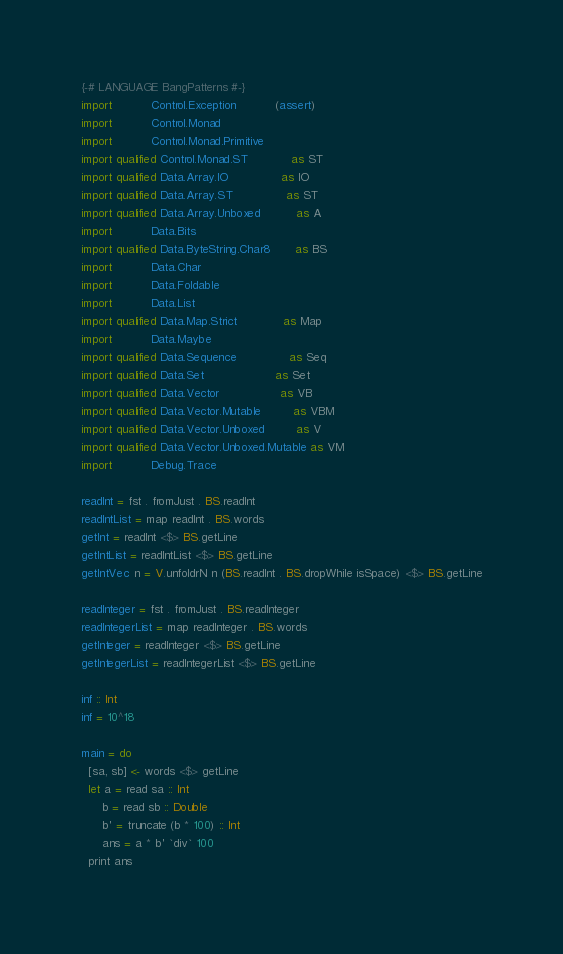<code> <loc_0><loc_0><loc_500><loc_500><_Haskell_>{-# LANGUAGE BangPatterns #-}
import           Control.Exception           (assert)
import           Control.Monad
import           Control.Monad.Primitive
import qualified Control.Monad.ST            as ST
import qualified Data.Array.IO               as IO
import qualified Data.Array.ST               as ST
import qualified Data.Array.Unboxed          as A
import           Data.Bits
import qualified Data.ByteString.Char8       as BS
import           Data.Char
import           Data.Foldable
import           Data.List
import qualified Data.Map.Strict             as Map
import           Data.Maybe
import qualified Data.Sequence               as Seq
import qualified Data.Set                    as Set
import qualified Data.Vector                 as VB
import qualified Data.Vector.Mutable         as VBM
import qualified Data.Vector.Unboxed         as V
import qualified Data.Vector.Unboxed.Mutable as VM
import           Debug.Trace

readInt = fst . fromJust . BS.readInt
readIntList = map readInt . BS.words
getInt = readInt <$> BS.getLine
getIntList = readIntList <$> BS.getLine
getIntVec n = V.unfoldrN n (BS.readInt . BS.dropWhile isSpace) <$> BS.getLine

readInteger = fst . fromJust . BS.readInteger
readIntegerList = map readInteger . BS.words
getInteger = readInteger <$> BS.getLine
getIntegerList = readIntegerList <$> BS.getLine

inf :: Int
inf = 10^18

main = do
  [sa, sb] <- words <$> getLine
  let a = read sa :: Int
      b = read sb :: Double
      b' = truncate (b * 100) :: Int
      ans = a * b' `div` 100
  print ans
</code> 